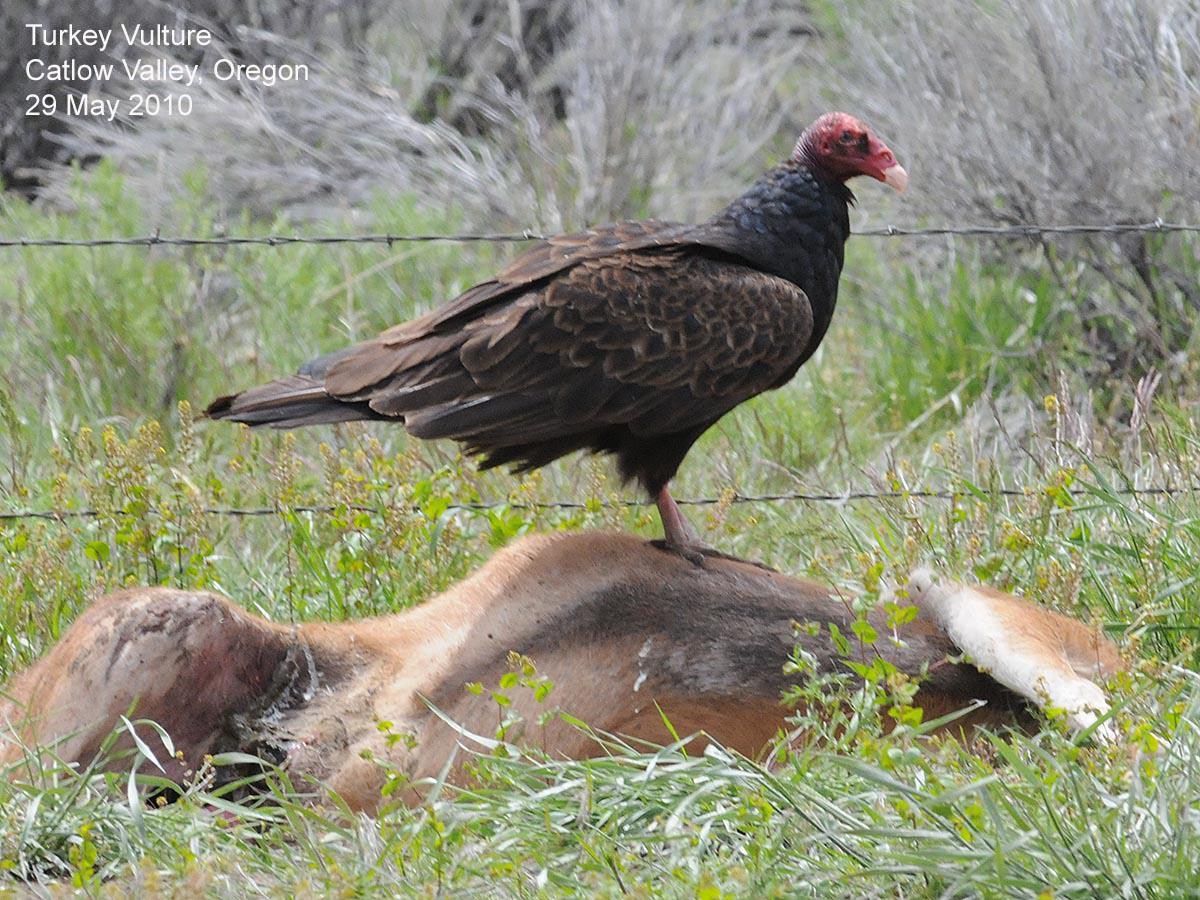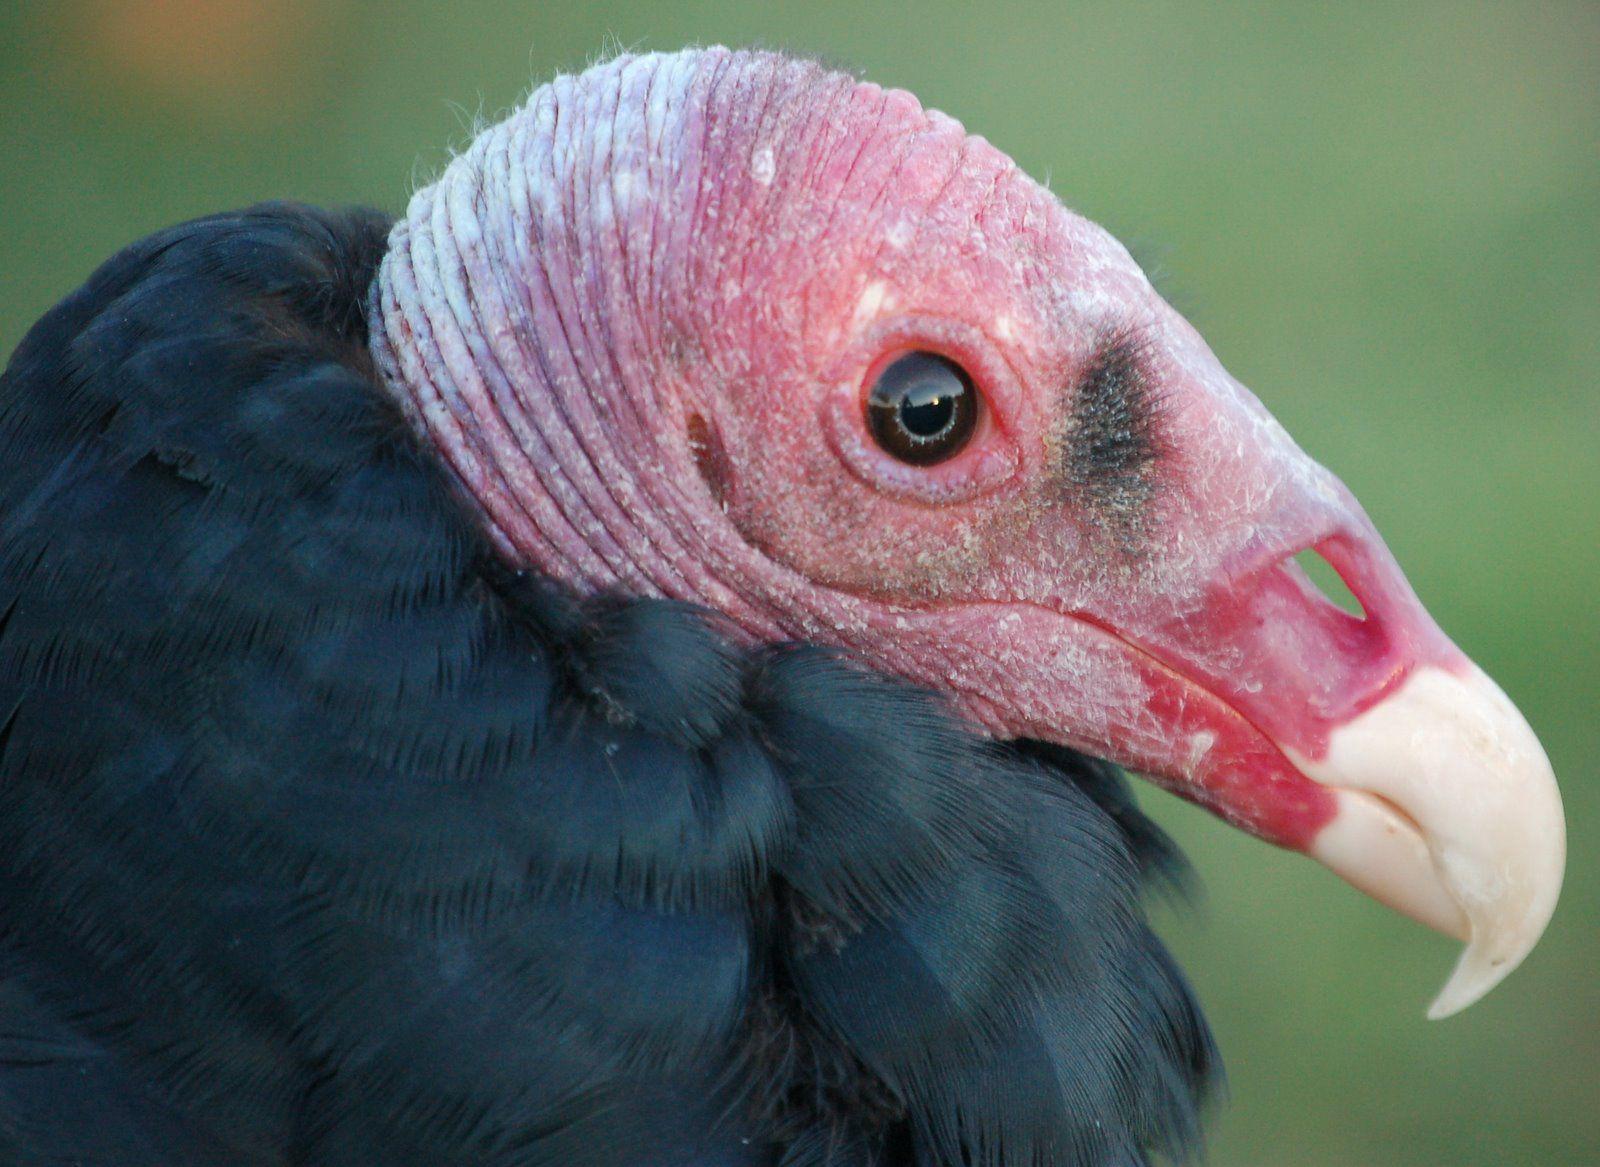The first image is the image on the left, the second image is the image on the right. Analyze the images presented: Is the assertion "An image shows one vulture perched on a wooden limb." valid? Answer yes or no. No. The first image is the image on the left, the second image is the image on the right. Given the left and right images, does the statement "At least one buzzard is standing on a dead animal in one of the images." hold true? Answer yes or no. Yes. 